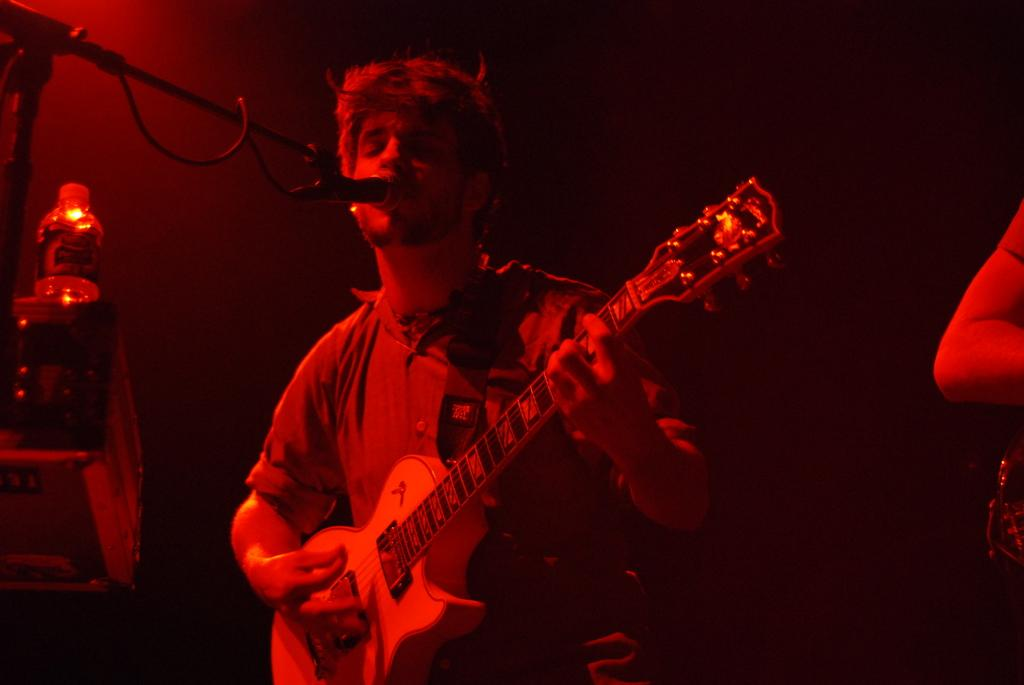What is the man in the image doing? The man is playing a guitar in the image. What object is present that is commonly used for amplifying sound? There is a microphone in the image. How many ducks are visible in the image? There are no ducks present in the image. What type of house is the man playing the guitar in? The provided facts do not mention a house or any specific location, so we cannot determine the type of house in the image. 